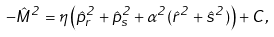Convert formula to latex. <formula><loc_0><loc_0><loc_500><loc_500>- \hat { M } ^ { 2 } = \eta \left ( \hat { p } _ { r } ^ { 2 } + \hat { p } _ { s } ^ { 2 } + \alpha ^ { 2 } ( \hat { r } ^ { 2 } + \hat { s } ^ { 2 } ) \right ) + C ,</formula> 